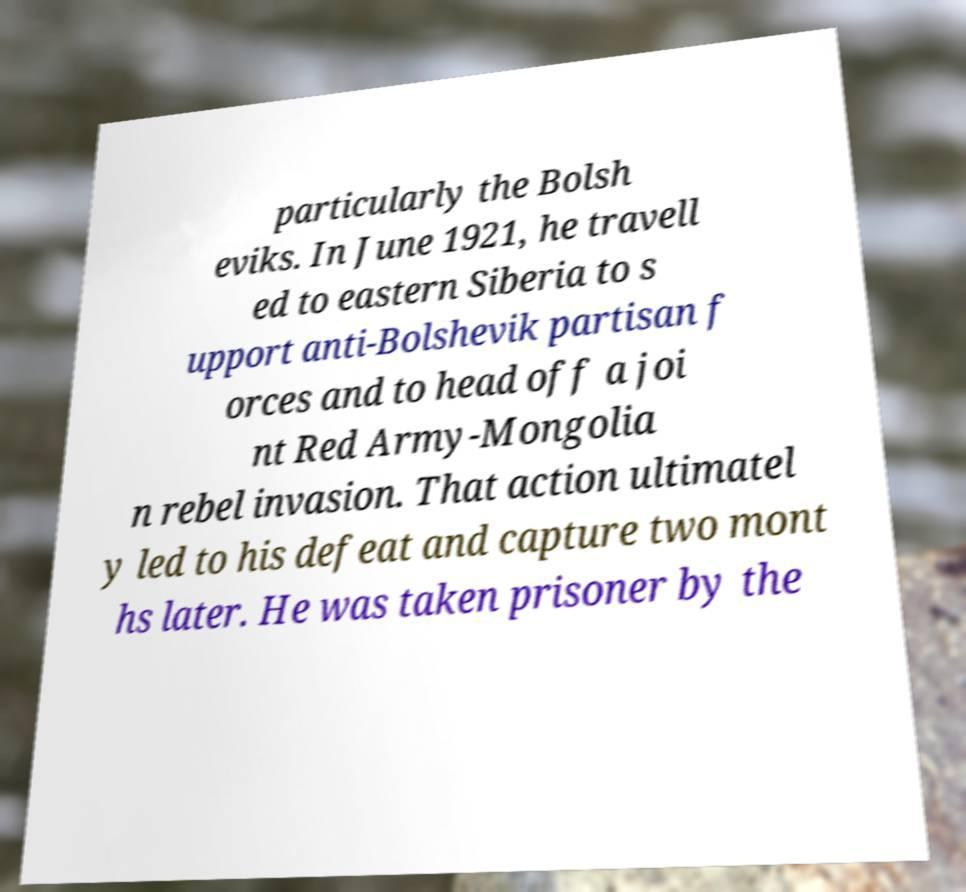There's text embedded in this image that I need extracted. Can you transcribe it verbatim? particularly the Bolsh eviks. In June 1921, he travell ed to eastern Siberia to s upport anti-Bolshevik partisan f orces and to head off a joi nt Red Army-Mongolia n rebel invasion. That action ultimatel y led to his defeat and capture two mont hs later. He was taken prisoner by the 